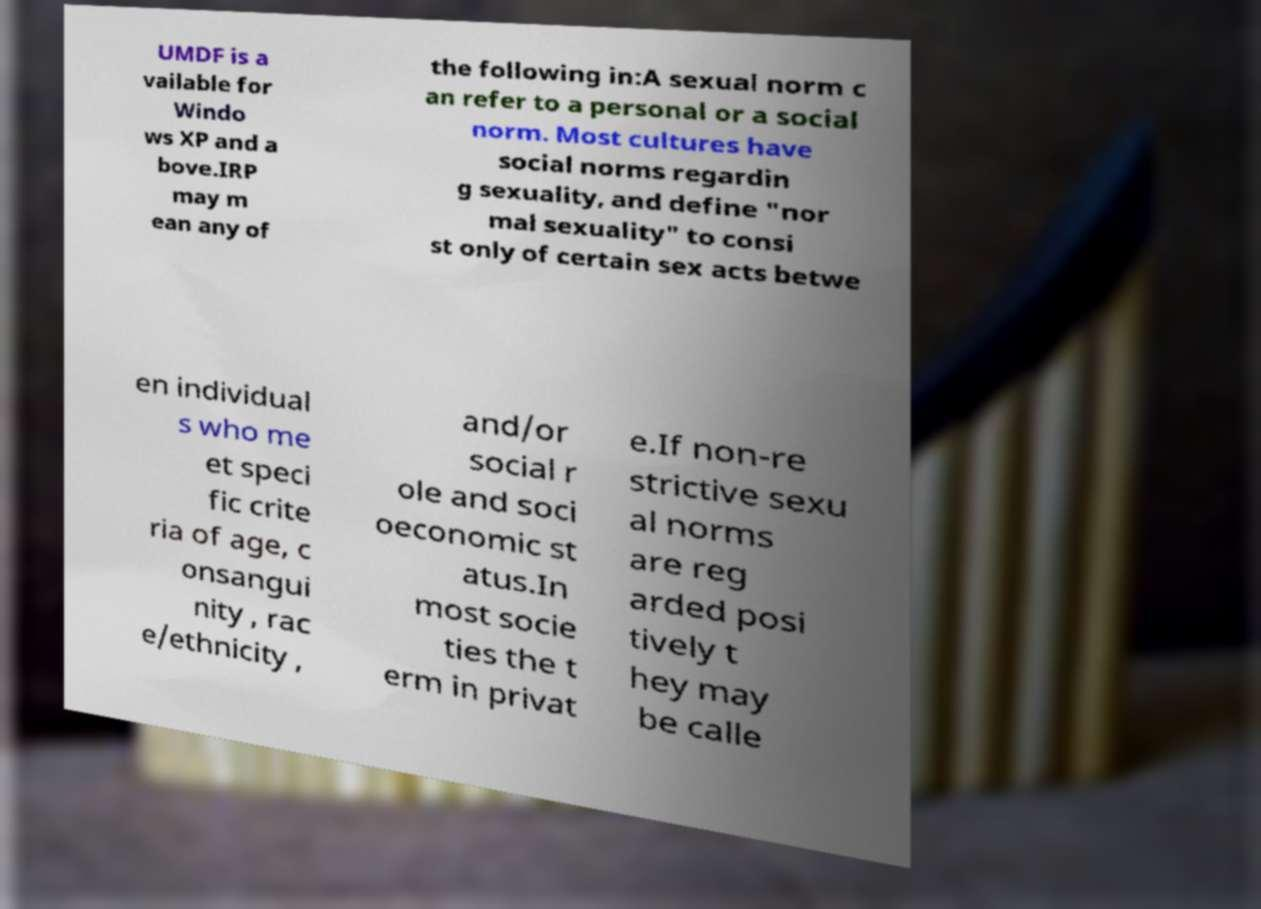Could you extract and type out the text from this image? UMDF is a vailable for Windo ws XP and a bove.IRP may m ean any of the following in:A sexual norm c an refer to a personal or a social norm. Most cultures have social norms regardin g sexuality, and define "nor mal sexuality" to consi st only of certain sex acts betwe en individual s who me et speci fic crite ria of age, c onsangui nity , rac e/ethnicity , and/or social r ole and soci oeconomic st atus.In most socie ties the t erm in privat e.If non-re strictive sexu al norms are reg arded posi tively t hey may be calle 